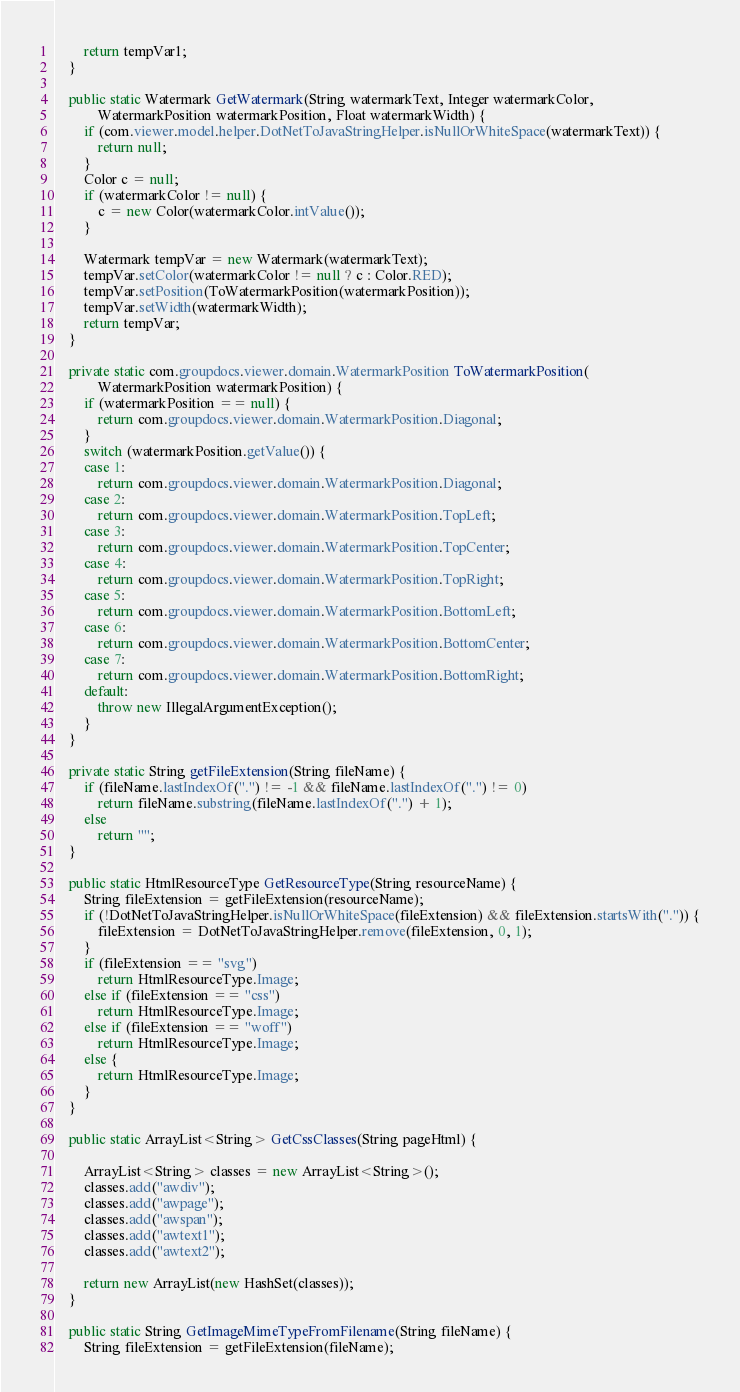Convert code to text. <code><loc_0><loc_0><loc_500><loc_500><_Java_>		return tempVar1;
	}

	public static Watermark GetWatermark(String watermarkText, Integer watermarkColor,
			WatermarkPosition watermarkPosition, Float watermarkWidth) {
		if (com.viewer.model.helper.DotNetToJavaStringHelper.isNullOrWhiteSpace(watermarkText)) {
			return null;
		}
		Color c = null;
		if (watermarkColor != null) {
			c = new Color(watermarkColor.intValue());
		}

		Watermark tempVar = new Watermark(watermarkText);
		tempVar.setColor(watermarkColor != null ? c : Color.RED);
		tempVar.setPosition(ToWatermarkPosition(watermarkPosition));
		tempVar.setWidth(watermarkWidth);
		return tempVar;
	}

	private static com.groupdocs.viewer.domain.WatermarkPosition ToWatermarkPosition(
			WatermarkPosition watermarkPosition) {
		if (watermarkPosition == null) {
			return com.groupdocs.viewer.domain.WatermarkPosition.Diagonal;
		}
		switch (watermarkPosition.getValue()) {
		case 1:
			return com.groupdocs.viewer.domain.WatermarkPosition.Diagonal;
		case 2:
			return com.groupdocs.viewer.domain.WatermarkPosition.TopLeft;
		case 3:
			return com.groupdocs.viewer.domain.WatermarkPosition.TopCenter;
		case 4:
			return com.groupdocs.viewer.domain.WatermarkPosition.TopRight;
		case 5:
			return com.groupdocs.viewer.domain.WatermarkPosition.BottomLeft;
		case 6:
			return com.groupdocs.viewer.domain.WatermarkPosition.BottomCenter;
		case 7:
			return com.groupdocs.viewer.domain.WatermarkPosition.BottomRight;
		default:
			throw new IllegalArgumentException();
		}
	}

	private static String getFileExtension(String fileName) {
		if (fileName.lastIndexOf(".") != -1 && fileName.lastIndexOf(".") != 0)
			return fileName.substring(fileName.lastIndexOf(".") + 1);
		else
			return "";
	}

	public static HtmlResourceType GetResourceType(String resourceName) {
		String fileExtension = getFileExtension(resourceName);
		if (!DotNetToJavaStringHelper.isNullOrWhiteSpace(fileExtension) && fileExtension.startsWith(".")) {
			fileExtension = DotNetToJavaStringHelper.remove(fileExtension, 0, 1);
		}
		if (fileExtension == "svg")
			return HtmlResourceType.Image;
		else if (fileExtension == "css")
			return HtmlResourceType.Image;
		else if (fileExtension == "woff")
			return HtmlResourceType.Image;
		else {
			return HtmlResourceType.Image;
		}
	}

	public static ArrayList<String> GetCssClasses(String pageHtml) {

		ArrayList<String> classes = new ArrayList<String>();
		classes.add("awdiv");
		classes.add("awpage");
		classes.add("awspan");
		classes.add("awtext1");
		classes.add("awtext2");

		return new ArrayList(new HashSet(classes)); 
	}

	public static String GetImageMimeTypeFromFilename(String fileName) {
		String fileExtension = getFileExtension(fileName);</code> 